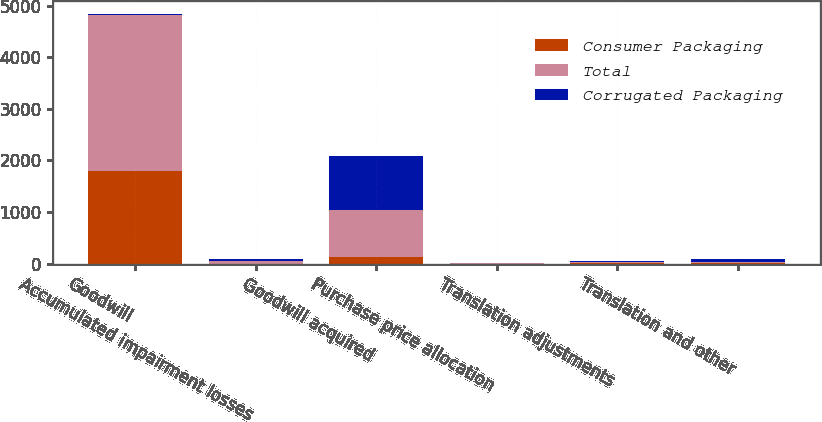<chart> <loc_0><loc_0><loc_500><loc_500><stacked_bar_chart><ecel><fcel>Goodwill<fcel>Accumulated impairment losses<fcel>Goodwill acquired<fcel>Purchase price allocation<fcel>Translation adjustments<fcel>Translation and other<nl><fcel>Consumer Packaging<fcel>1798.4<fcel>0.1<fcel>137.6<fcel>1.2<fcel>6.8<fcel>19<nl><fcel>Total<fcel>3022.5<fcel>42.7<fcel>907.8<fcel>9.3<fcel>19.5<fcel>22.7<nl><fcel>Corrugated Packaging<fcel>26.3<fcel>42.8<fcel>1045.4<fcel>8.1<fcel>26.3<fcel>41.7<nl></chart> 